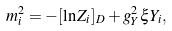<formula> <loc_0><loc_0><loc_500><loc_500>m _ { i } ^ { 2 } = - [ \ln Z _ { i } ] _ { D } + g _ { Y } ^ { 2 } \xi Y _ { i } ,</formula> 